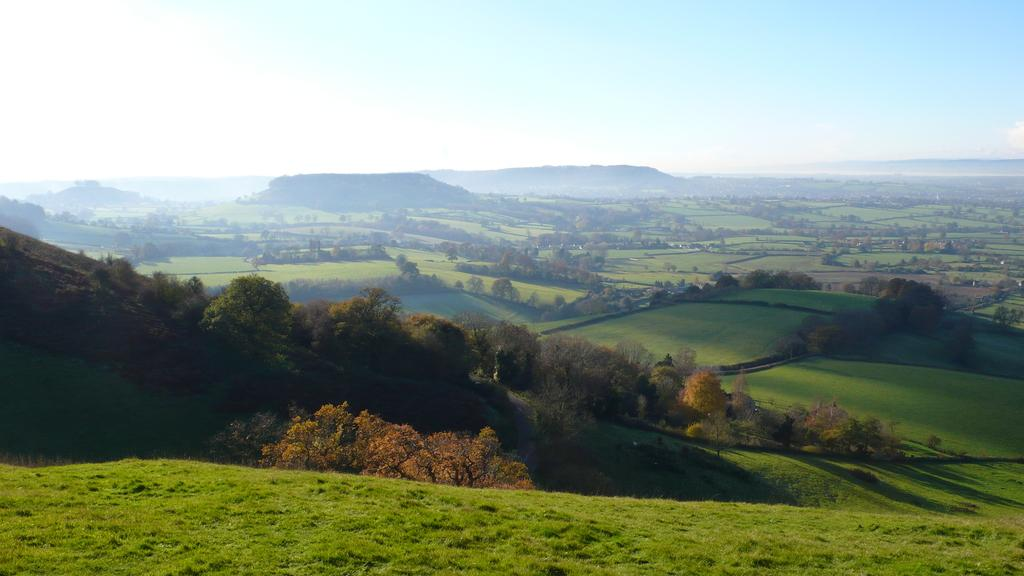What type of vegetation is present in the image? There is green grass in the image. What other natural elements can be seen in the image? There are trees in the image. What is visible in the background of the image? The sky is visible in the background of the image. How would you describe the sky in the image? The sky appears to be clear in the image. How does the grass increase its polish in the image? There is no indication in the image that the grass is polished or that it is capable of increasing its polish. --- Facts: 1. There is a person sitting on a bench in the image. 2. The person is reading a book. 3. The bench is located near a body of water. 4. There are trees in the background of the image. 5. The sky is visible in the background of the image. Absurd Topics: dance, volcano, parrot Conversation: What is the person in the image doing? The person is sitting on a bench and reading a book in the image. Where is the bench located? The bench is located near a body of water in the image. What can be seen in the background of the image? There are trees and the sky visible in the background of the image. Reasoning: Let's think step by step in order to produce the conversation. We start by identifying the main subject in the image, which is the person sitting on the bench. Then, we describe what the person is doing, which is reading a book. Next, we expand the conversation to include the location of the bench, which is near a body of water. Finally, we mention the background elements, which are trees and the sky. Absurd Question/Answer: Can you see any volcanoes or parrots in the image? No, there are no volcanoes or parrots present in the image. 